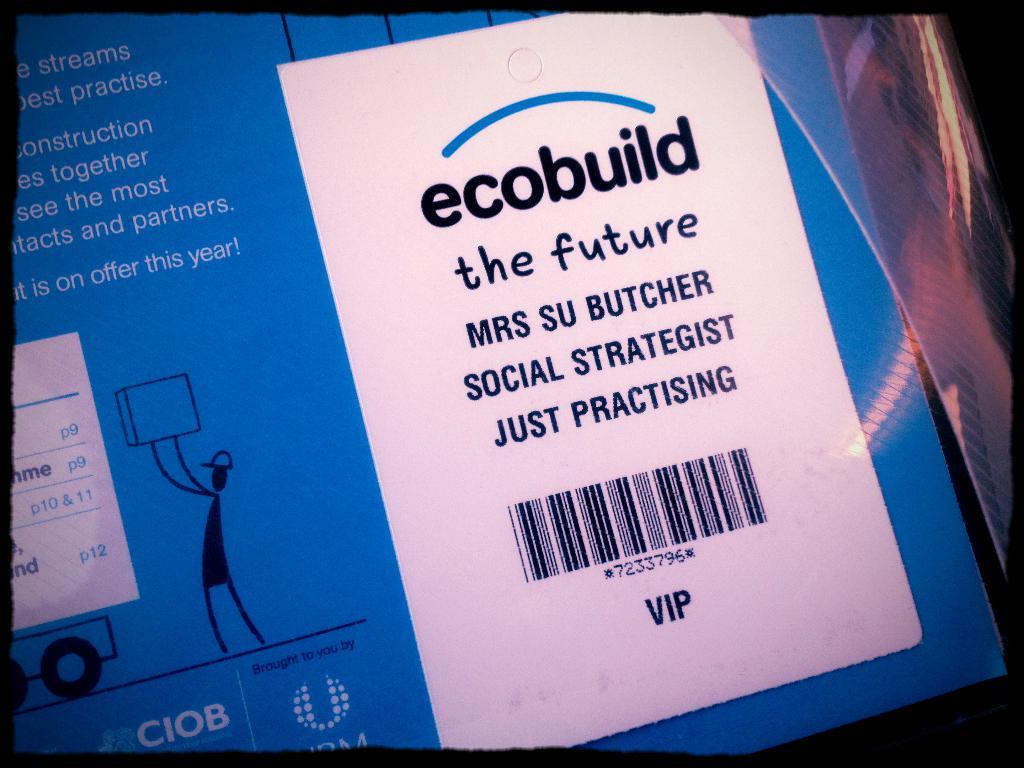<image>
Share a concise interpretation of the image provided. A package with a bar code for ecobuild the future. 